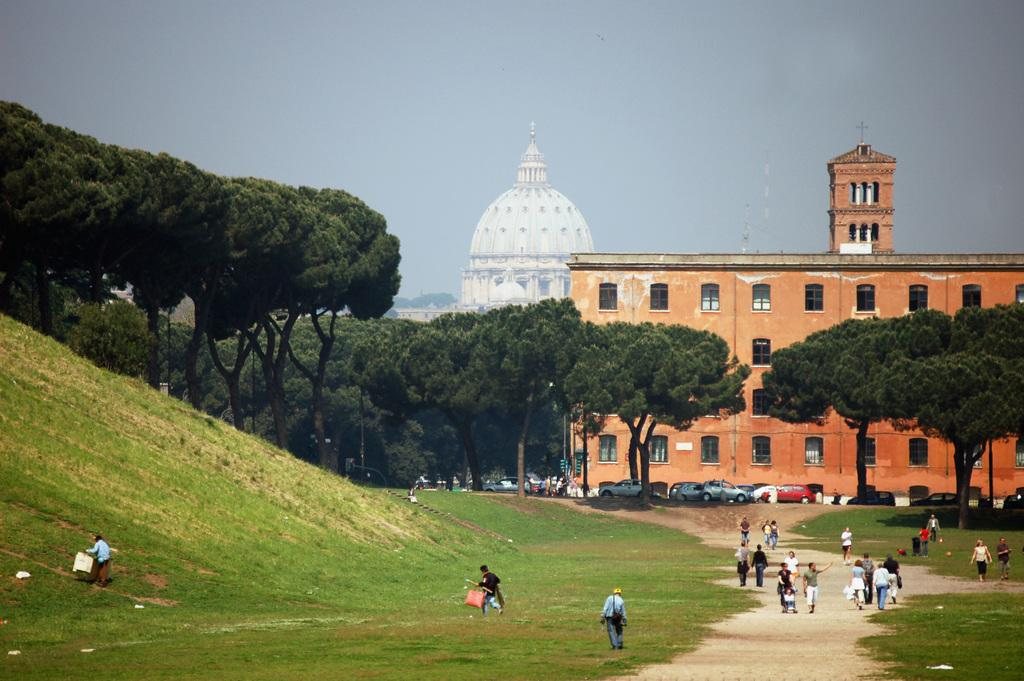What type of structures can be seen in the image? There are buildings in the image. What natural elements are present in the image? There are trees in the image. What type of vehicles can be seen in the image? Cars are visible in the image. Are there any living beings in the image? Yes, there are people in the image. What geographical feature is present in the image? There is a hill in the image. What is visible in the background of the image? The sky is visible in the background of the image. How many boats are sailing on the wave in the image? There are no boats or waves present in the image; it features buildings, trees, cars, people, a hill, and the sky. 